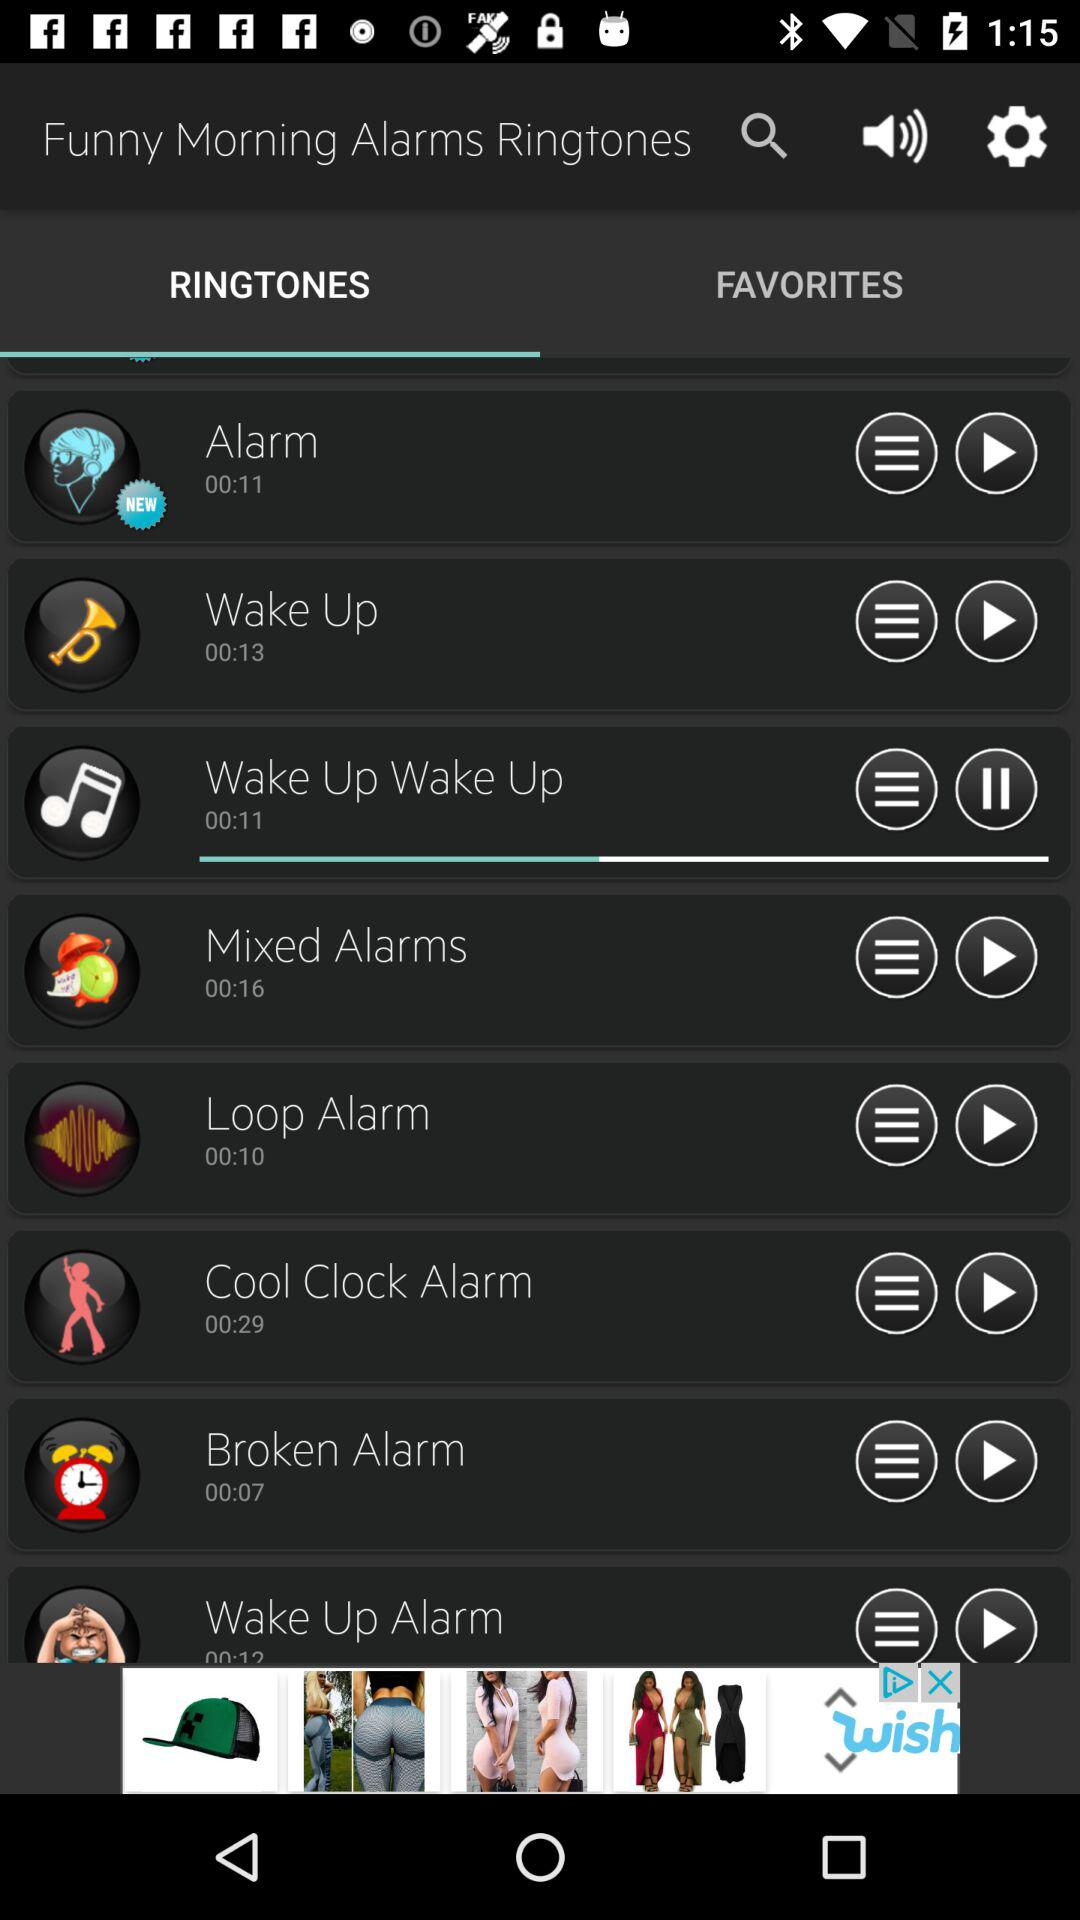Which tab is selected? The selected tab is Ringtones. 